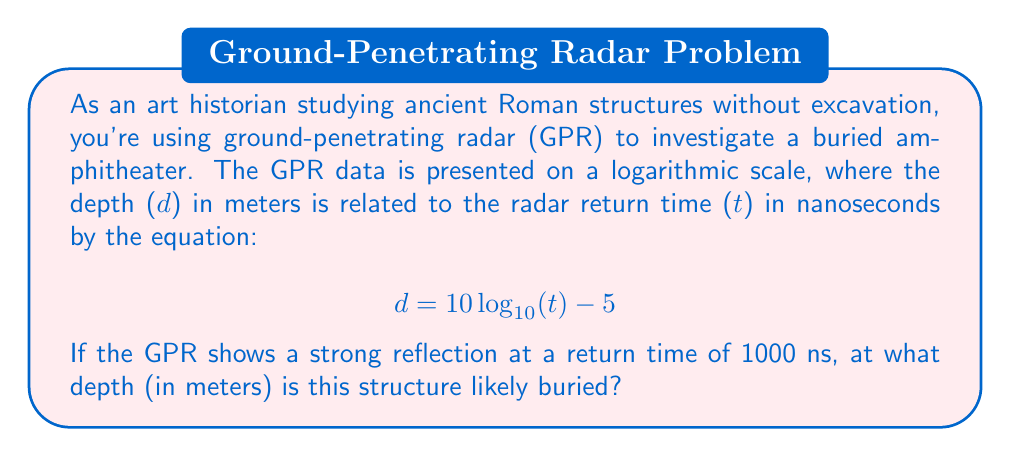What is the answer to this math problem? To solve this problem, we need to use the given logarithmic equation and substitute the known return time value. Let's break it down step-by-step:

1. We are given the equation:
   $$ d = 10 \log_{10}(t) - 5 $$

2. We know that the return time $t = 1000$ ns. Let's substitute this into the equation:
   $$ d = 10 \log_{10}(1000) - 5 $$

3. Now, let's solve the logarithm:
   $\log_{10}(1000) = 3$ (since $10^3 = 1000$)

4. Substituting this value:
   $$ d = 10(3) - 5 $$

5. Simplify:
   $$ d = 30 - 5 = 25 $$

Therefore, the structure is likely buried at a depth of 25 meters.

This method allows us to non-invasively estimate the depth of buried structures, which is crucial for preserving the integrity of archaeological sites while still gathering valuable information about their dimensions and layout.
Answer: 25 meters 